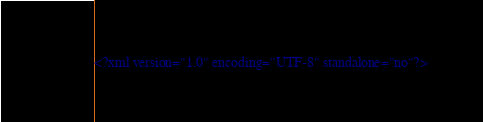<code> <loc_0><loc_0><loc_500><loc_500><_HTML_><?xml version="1.0" encoding="UTF-8" standalone="no"?></code> 